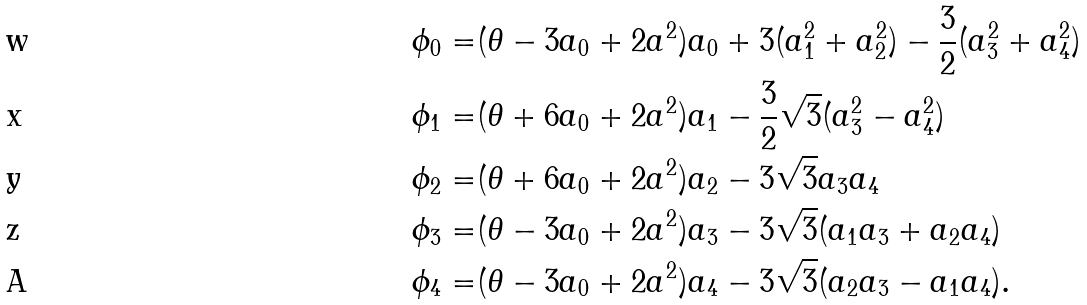Convert formula to latex. <formula><loc_0><loc_0><loc_500><loc_500>\phi _ { 0 } = & ( { \theta } - 3 a _ { 0 } + 2 a ^ { 2 } ) a _ { 0 } + 3 ( a ^ { 2 } _ { 1 } + a ^ { 2 } _ { 2 } ) - { \frac { 3 } { 2 } } ( a ^ { 2 } _ { 3 } + a ^ { 2 } _ { 4 } ) \\ \phi _ { 1 } = & ( { \theta } + 6 a _ { 0 } + 2 a ^ { 2 } ) a _ { 1 } - { \frac { 3 } { 2 } } { \sqrt { 3 } } ( a ^ { 2 } _ { 3 } - a ^ { 2 } _ { 4 } ) \\ \phi _ { 2 } = & ( { \theta } + 6 a _ { 0 } + 2 a ^ { 2 } ) a _ { 2 } - 3 { \sqrt { 3 } } a _ { 3 } a _ { 4 } \\ \phi _ { 3 } = & ( { \theta } - 3 a _ { 0 } + 2 a ^ { 2 } ) a _ { 3 } - 3 { \sqrt { 3 } } ( a _ { 1 } a _ { 3 } + a _ { 2 } a _ { 4 } ) \\ \phi _ { 4 } = & ( { \theta } - 3 a _ { 0 } + 2 a ^ { 2 } ) a _ { 4 } - 3 { \sqrt { 3 } } ( a _ { 2 } a _ { 3 } - a _ { 1 } a _ { 4 } ) .</formula> 